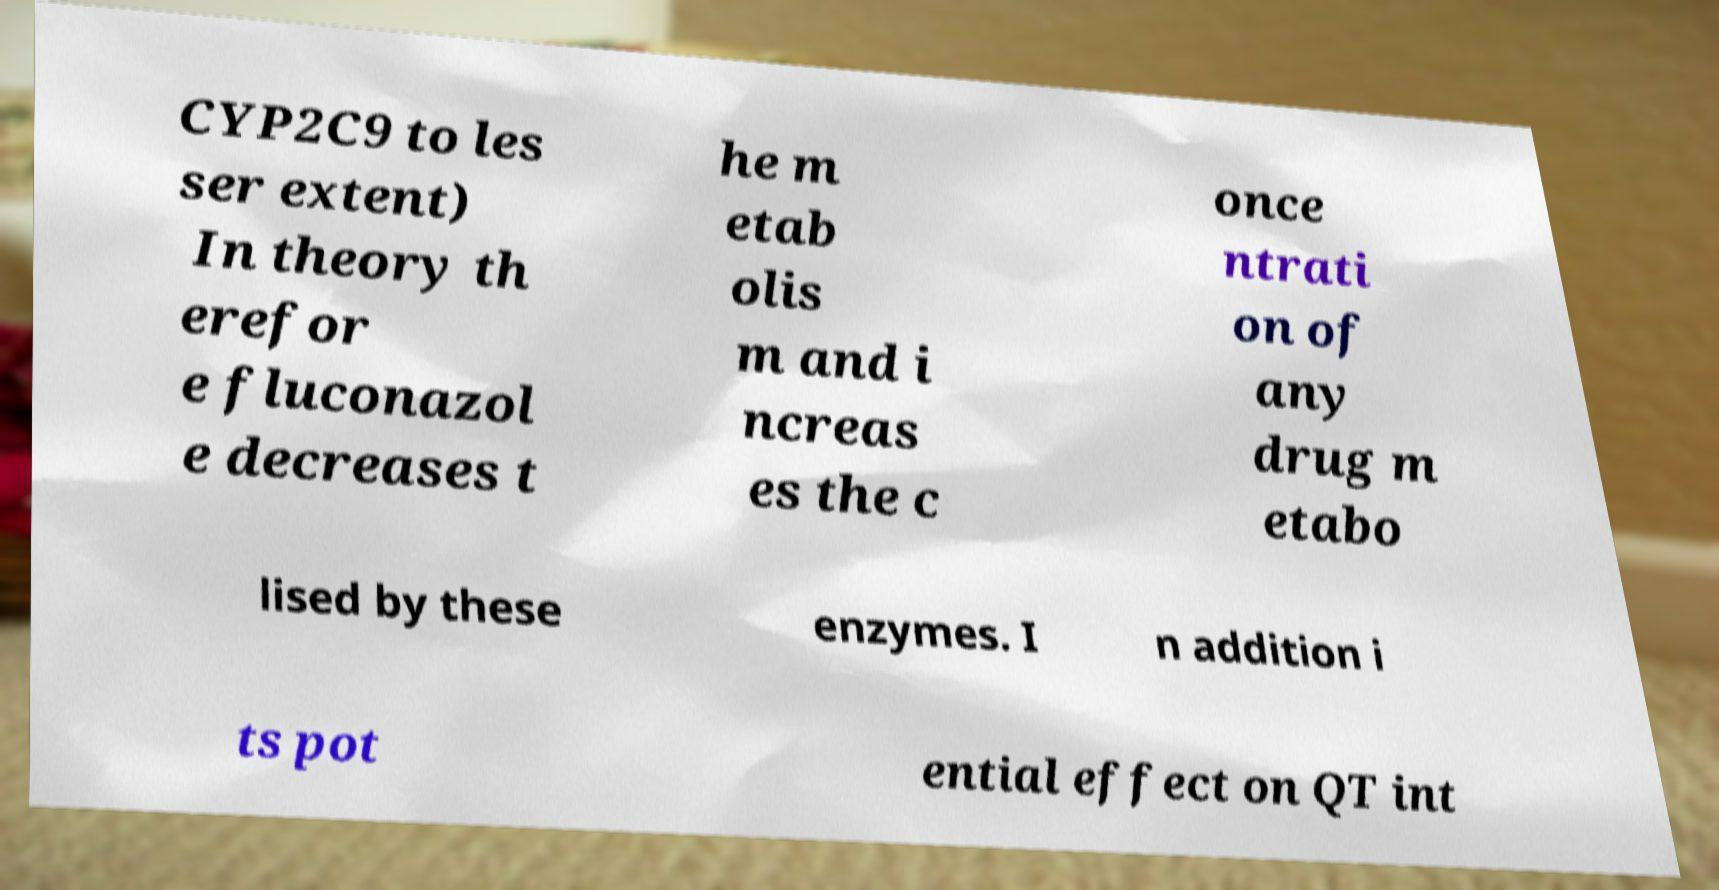What messages or text are displayed in this image? I need them in a readable, typed format. CYP2C9 to les ser extent) In theory th erefor e fluconazol e decreases t he m etab olis m and i ncreas es the c once ntrati on of any drug m etabo lised by these enzymes. I n addition i ts pot ential effect on QT int 